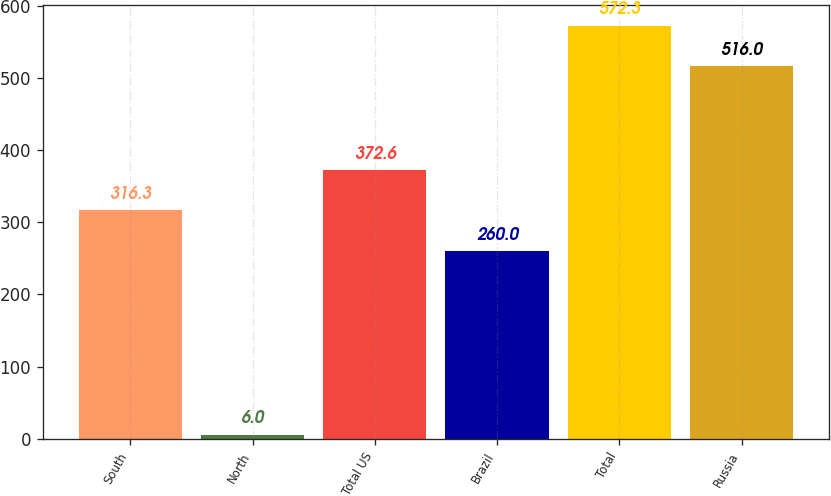<chart> <loc_0><loc_0><loc_500><loc_500><bar_chart><fcel>South<fcel>North<fcel>Total US<fcel>Brazil<fcel>Total<fcel>Russia<nl><fcel>316.3<fcel>6<fcel>372.6<fcel>260<fcel>572.3<fcel>516<nl></chart> 